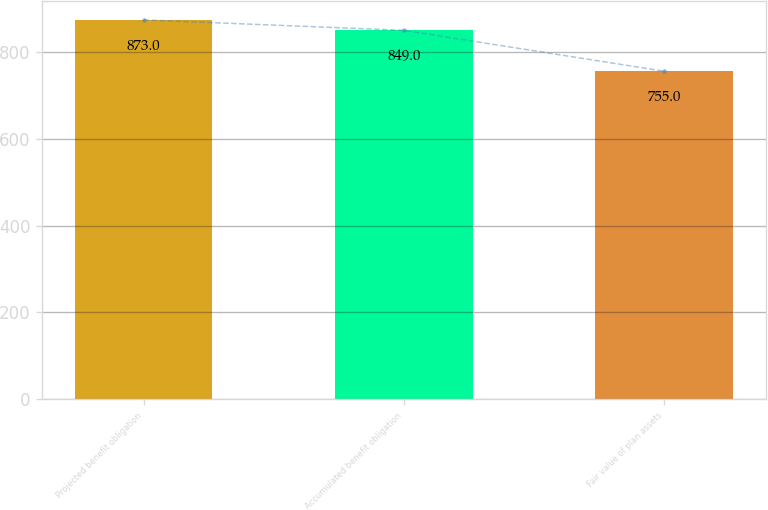Convert chart. <chart><loc_0><loc_0><loc_500><loc_500><bar_chart><fcel>Projected benefit obligation<fcel>Accumulated benefit obligation<fcel>Fair value of plan assets<nl><fcel>873<fcel>849<fcel>755<nl></chart> 